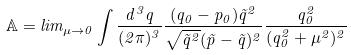<formula> <loc_0><loc_0><loc_500><loc_500>\mathbb { A } = l i m _ { \mu \rightarrow 0 } \int \frac { d ^ { 3 } q } { ( 2 \pi ) ^ { 3 } } \frac { ( q _ { 0 } - p _ { 0 } ) \vec { q } ^ { 2 } } { \sqrt { \vec { q } ^ { 2 } } ( \vec { p } - \vec { q } ) ^ { 2 } } \frac { q _ { 0 } ^ { 2 } } { ( q _ { 0 } ^ { 2 } + \mu ^ { 2 } ) ^ { 2 } }</formula> 